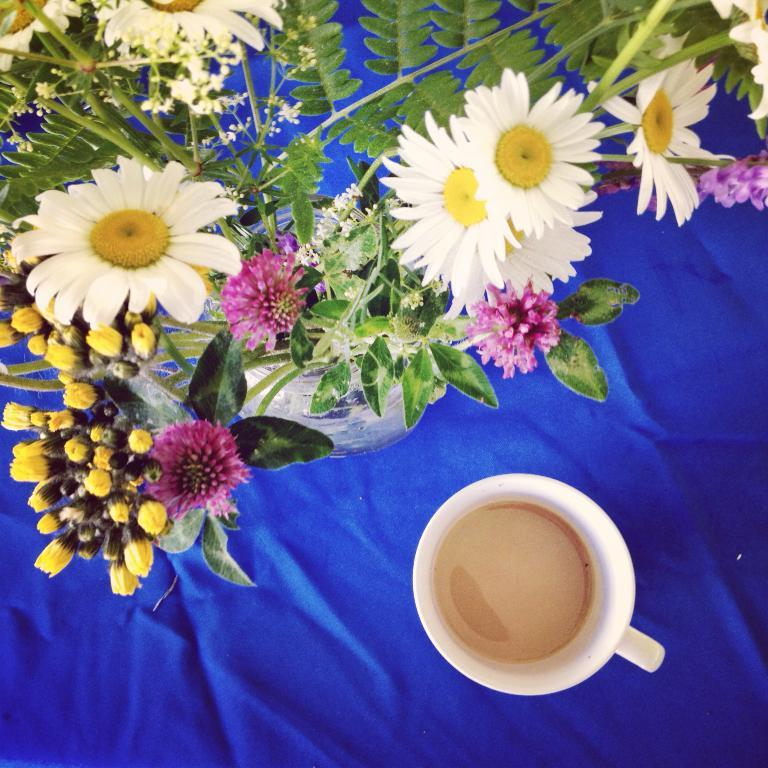What type of furniture is in the image? There is a table in the image. What is covering the table? A blue colored cloth is present on the table. What can be seen on top of the blue cloth? There is a flower vase and a cup of coffee on the blue cloth. Is there a camping trip happening in the image? There is no indication of a camping trip in the image; it features a table with a blue cloth, a flower vase, and a cup of coffee. 